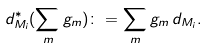<formula> <loc_0><loc_0><loc_500><loc_500>d _ { M _ { i } } ^ { \ast } ( \sum _ { m } g _ { m } ) \colon = \sum _ { m } g _ { m } \, d _ { M _ { i } } .</formula> 